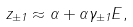Convert formula to latex. <formula><loc_0><loc_0><loc_500><loc_500>z _ { \pm 1 } \approx \alpha + \alpha \gamma _ { \pm 1 } E ,</formula> 